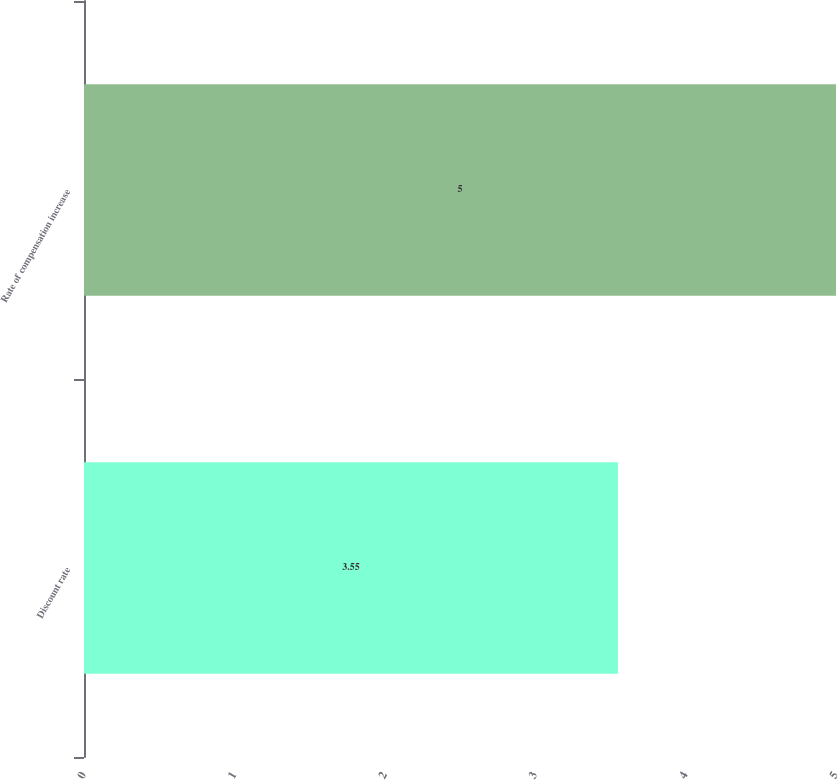Convert chart. <chart><loc_0><loc_0><loc_500><loc_500><bar_chart><fcel>Discount rate<fcel>Rate of compensation increase<nl><fcel>3.55<fcel>5<nl></chart> 